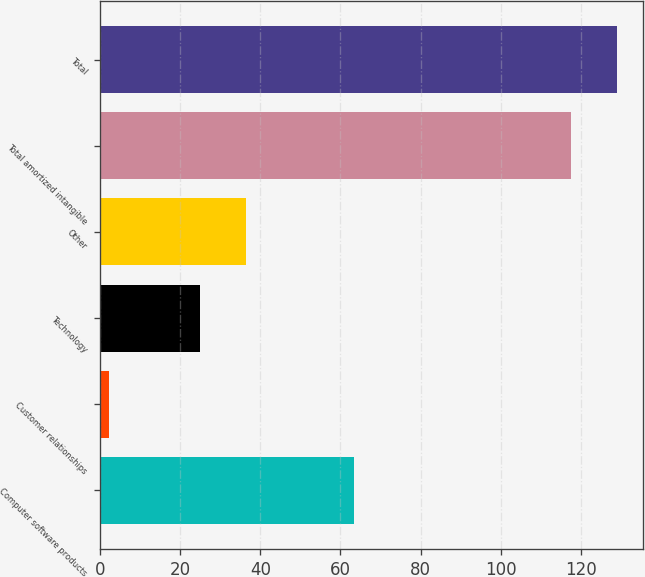Convert chart. <chart><loc_0><loc_0><loc_500><loc_500><bar_chart><fcel>Computer software products<fcel>Customer relationships<fcel>Technology<fcel>Other<fcel>Total amortized intangible<fcel>Total<nl><fcel>63.5<fcel>2.1<fcel>25<fcel>36.54<fcel>117.5<fcel>129.04<nl></chart> 